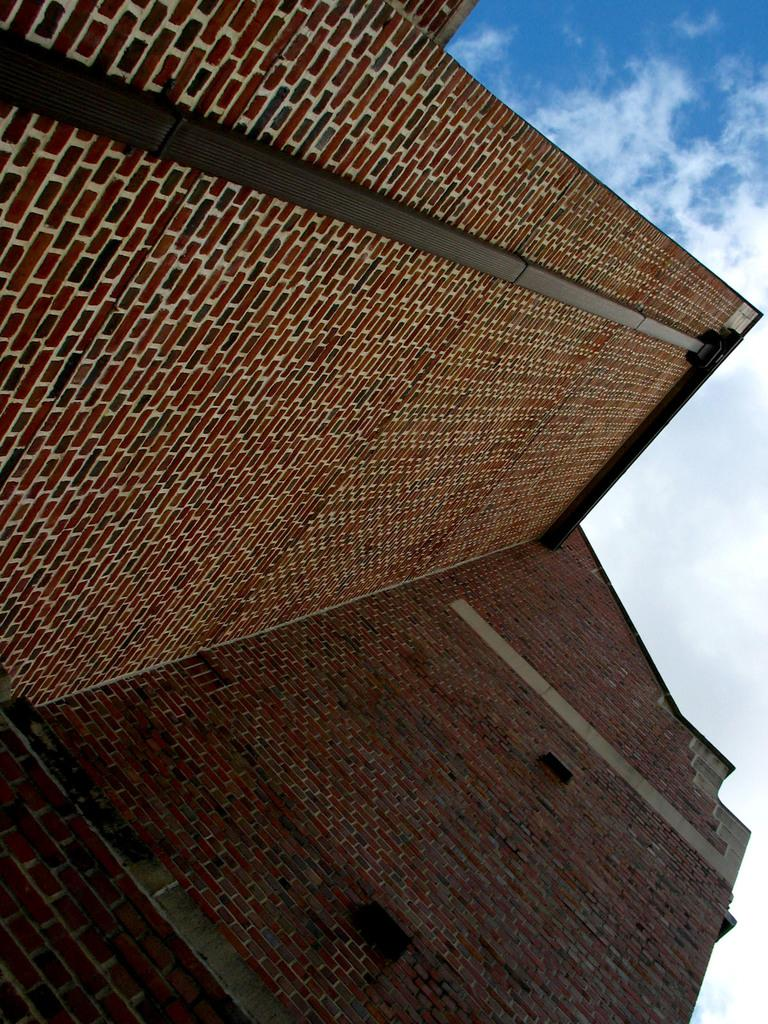What type of building is in the image? There is a brick building in the image. What part of the natural environment is visible in the image? The sky is visible in the image. What can be seen in the sky? Clouds are present in the sky. How many eggs are visible on the roof of the brick building in the image? There are no eggs visible on the roof of the brick building in the image. 